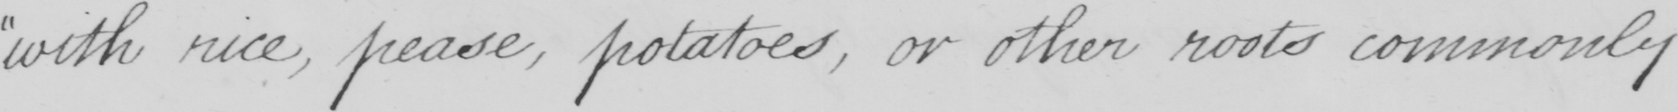Transcribe the text shown in this historical manuscript line. with rice , pease , potatoes , or other roots commonly 